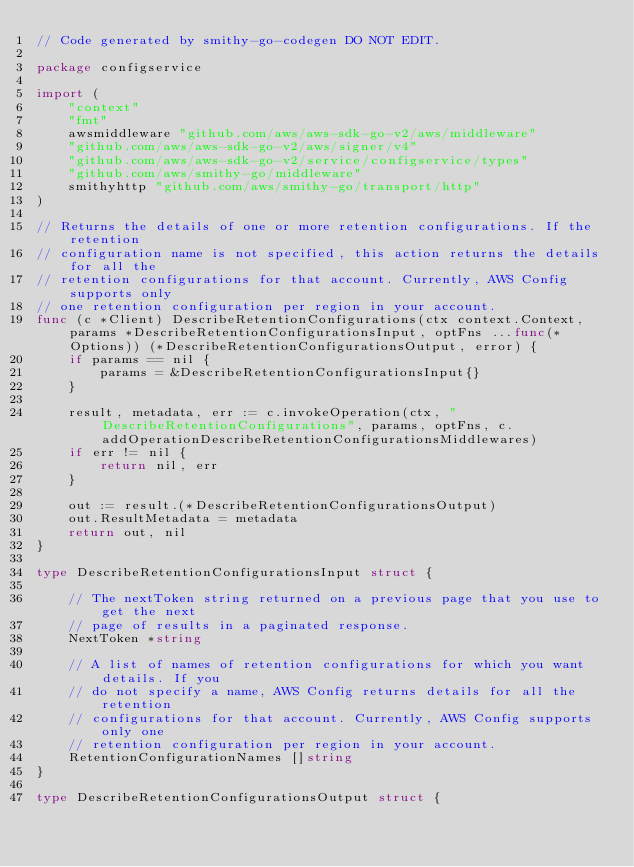<code> <loc_0><loc_0><loc_500><loc_500><_Go_>// Code generated by smithy-go-codegen DO NOT EDIT.

package configservice

import (
	"context"
	"fmt"
	awsmiddleware "github.com/aws/aws-sdk-go-v2/aws/middleware"
	"github.com/aws/aws-sdk-go-v2/aws/signer/v4"
	"github.com/aws/aws-sdk-go-v2/service/configservice/types"
	"github.com/aws/smithy-go/middleware"
	smithyhttp "github.com/aws/smithy-go/transport/http"
)

// Returns the details of one or more retention configurations. If the retention
// configuration name is not specified, this action returns the details for all the
// retention configurations for that account. Currently, AWS Config supports only
// one retention configuration per region in your account.
func (c *Client) DescribeRetentionConfigurations(ctx context.Context, params *DescribeRetentionConfigurationsInput, optFns ...func(*Options)) (*DescribeRetentionConfigurationsOutput, error) {
	if params == nil {
		params = &DescribeRetentionConfigurationsInput{}
	}

	result, metadata, err := c.invokeOperation(ctx, "DescribeRetentionConfigurations", params, optFns, c.addOperationDescribeRetentionConfigurationsMiddlewares)
	if err != nil {
		return nil, err
	}

	out := result.(*DescribeRetentionConfigurationsOutput)
	out.ResultMetadata = metadata
	return out, nil
}

type DescribeRetentionConfigurationsInput struct {

	// The nextToken string returned on a previous page that you use to get the next
	// page of results in a paginated response.
	NextToken *string

	// A list of names of retention configurations for which you want details. If you
	// do not specify a name, AWS Config returns details for all the retention
	// configurations for that account. Currently, AWS Config supports only one
	// retention configuration per region in your account.
	RetentionConfigurationNames []string
}

type DescribeRetentionConfigurationsOutput struct {
</code> 